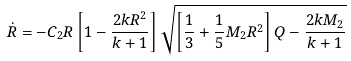Convert formula to latex. <formula><loc_0><loc_0><loc_500><loc_500>\dot { R } = - C _ { 2 } R \left [ 1 - \frac { 2 k R ^ { 2 } } { k + 1 } \right ] \sqrt { \left [ \frac { 1 } { 3 } + \frac { 1 } { 5 } M _ { 2 } R ^ { 2 } \right ] Q - \frac { 2 k M _ { 2 } } { k + 1 } }</formula> 